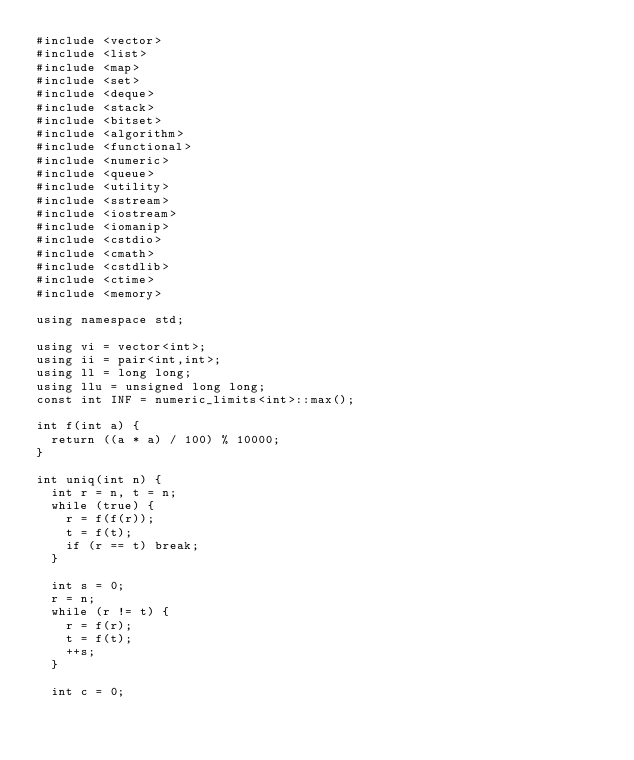Convert code to text. <code><loc_0><loc_0><loc_500><loc_500><_C++_>#include <vector>
#include <list>
#include <map>
#include <set>
#include <deque>
#include <stack>
#include <bitset>
#include <algorithm>
#include <functional>
#include <numeric>
#include <queue>
#include <utility>
#include <sstream>
#include <iostream>
#include <iomanip>
#include <cstdio>
#include <cmath>
#include <cstdlib>
#include <ctime>
#include <memory>

using namespace std;

using vi = vector<int>;
using ii = pair<int,int>;
using ll = long long;
using llu = unsigned long long;
const int INF = numeric_limits<int>::max();

int f(int a) {
  return ((a * a) / 100) % 10000;
}

int uniq(int n) {
  int r = n, t = n;
  while (true) {
    r = f(f(r));
    t = f(t);
    if (r == t) break;
  }

  int s = 0;
  r = n;
  while (r != t) {
    r = f(r);
    t = f(t);
    ++s;
  }

  int c = 0;</code> 